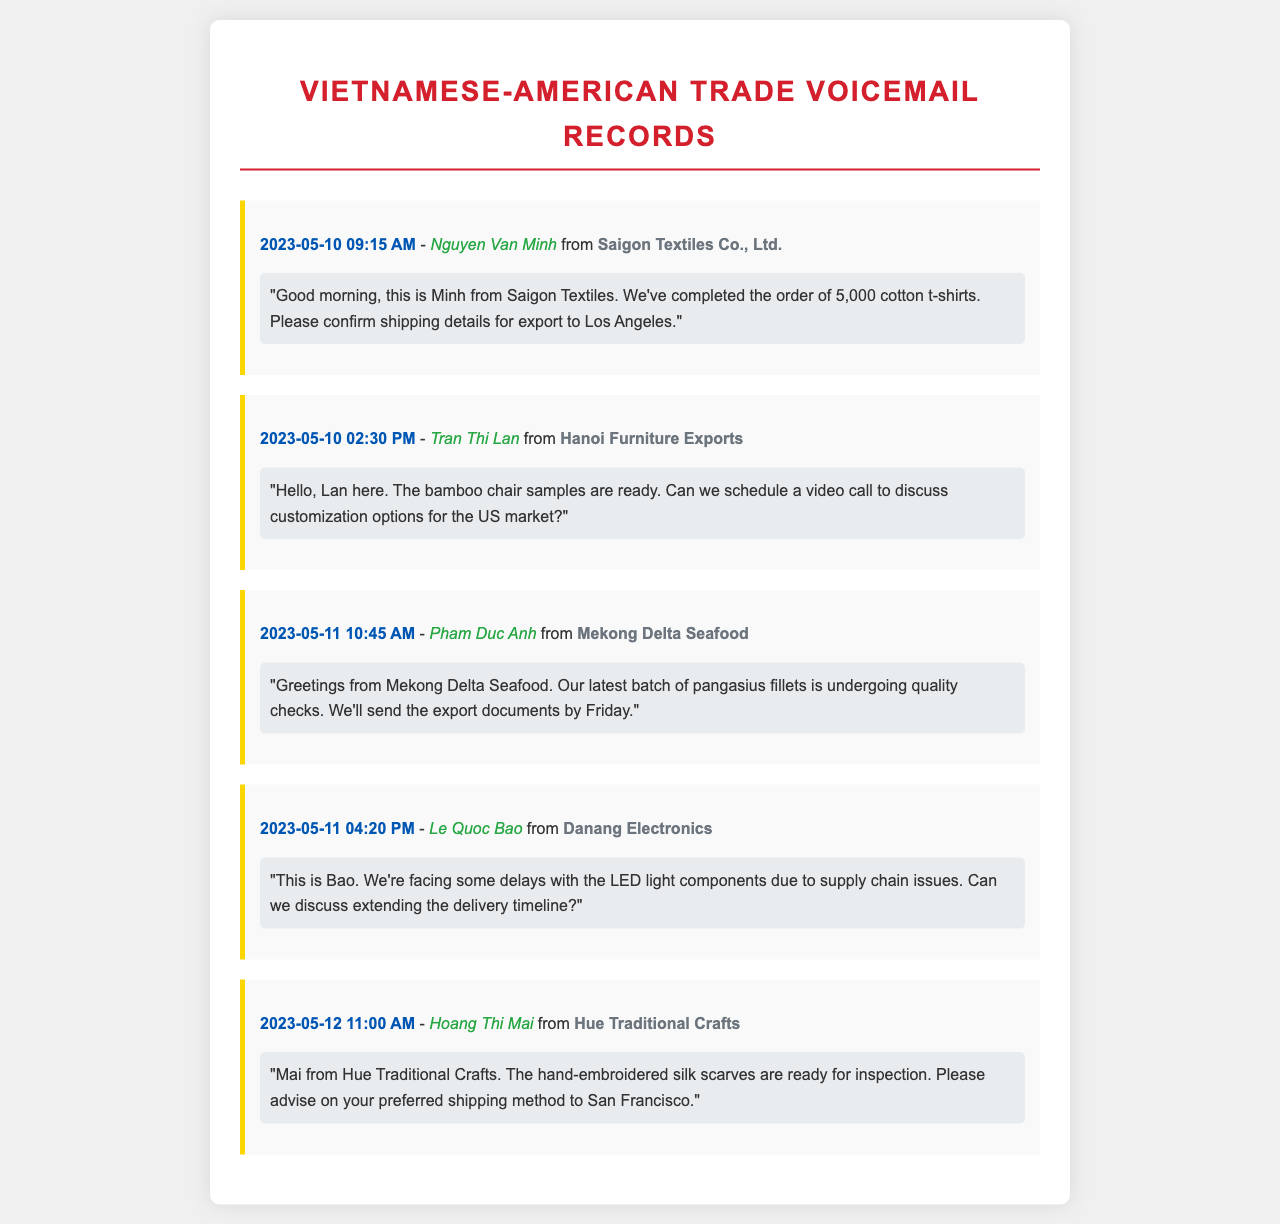What is the name of the caller from Saigon Textiles? The name of the caller from Saigon Textiles is mentioned at the top of the record, which is Nguyen Van Minh.
Answer: Nguyen Van Minh What date did Tran Thi Lan leave her message? The message from Tran Thi Lan is logged with a timestamp that shows it occurred on May 10, 2023.
Answer: May 10, 2023 How many t-shirts were ordered from Saigon Textiles? The message clearly states that the order consists of 5,000 cotton t-shirts.
Answer: 5,000 What is the main issue reported by Le Quoc Bao? The message from Le Quoc Bao indicates that the main issue is delays with the LED light components.
Answer: Delays What is the shipping destination for the silk scarves from Hue Traditional Crafts? The message specifies that the preferred shipping method is to San Francisco.
Answer: San Francisco What type of product is being discussed by Pham Duc Anh? Pham Duc Anh mentions pangasius fillets, identifying the type of product discussed in the message.
Answer: Pangasius fillets How many voicemail messages mention scheduling a call? Upon reviewing the records, two messages indicate a request to schedule a call: one from Tran Thi Lan and another potential mention if needed from Bao.
Answer: 2 Which company is facing quality checks on their products? The message from Pham Duc Anh from Mekong Delta Seafood indicates that they are undergoing quality checks for their products.
Answer: Mekong Delta Seafood What is the purpose of the message from Hoang Thi Mai? Hoang Thi Mai’s message is focused on notifying about the readiness of the hand-embroidered silk scarves for inspection.
Answer: Inspection 